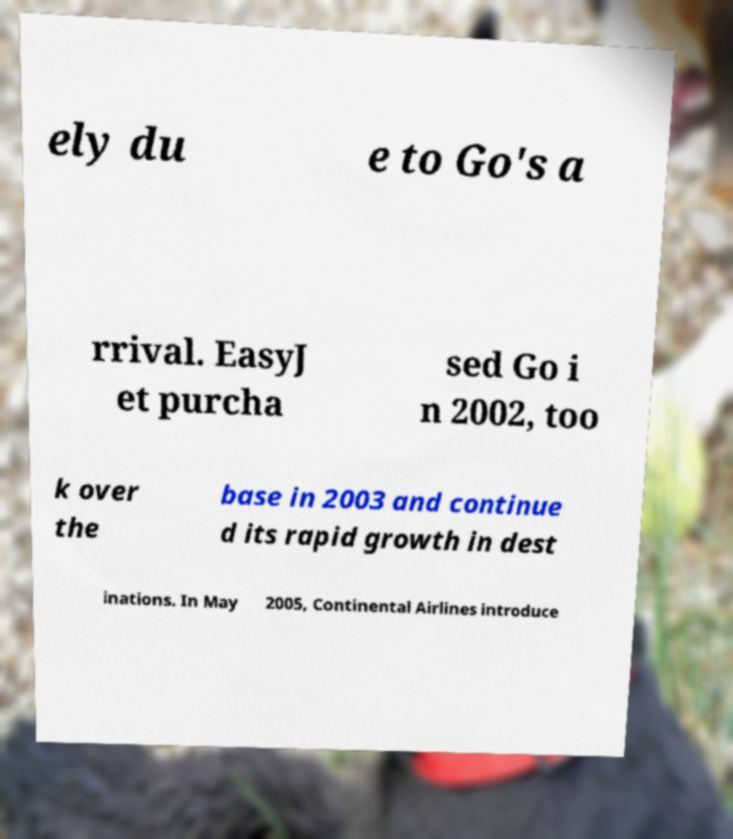Please read and relay the text visible in this image. What does it say? ely du e to Go's a rrival. EasyJ et purcha sed Go i n 2002, too k over the base in 2003 and continue d its rapid growth in dest inations. In May 2005, Continental Airlines introduce 